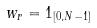<formula> <loc_0><loc_0><loc_500><loc_500>w _ { r } = 1 _ { [ 0 , N - 1 ] }</formula> 